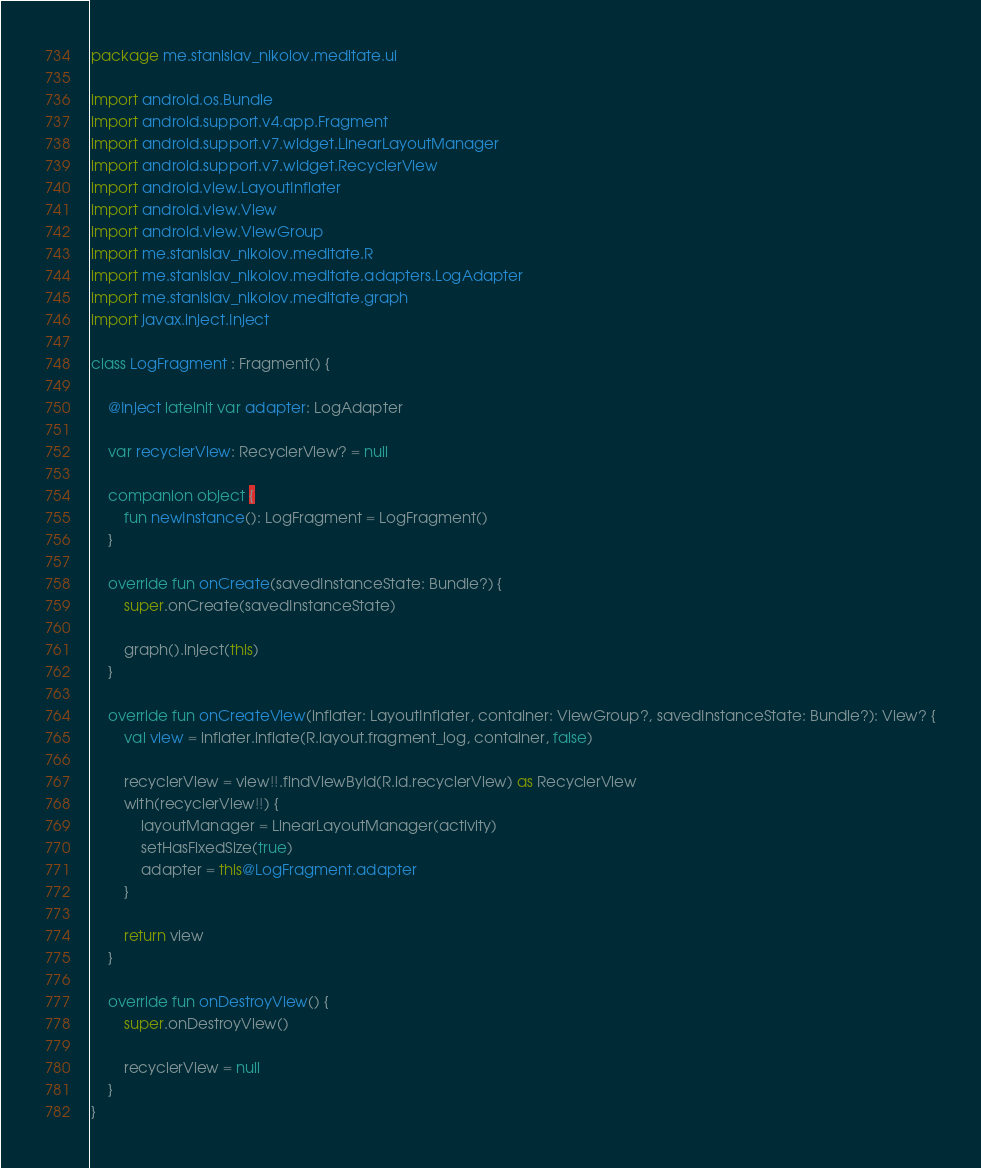Convert code to text. <code><loc_0><loc_0><loc_500><loc_500><_Kotlin_>package me.stanislav_nikolov.meditate.ui

import android.os.Bundle
import android.support.v4.app.Fragment
import android.support.v7.widget.LinearLayoutManager
import android.support.v7.widget.RecyclerView
import android.view.LayoutInflater
import android.view.View
import android.view.ViewGroup
import me.stanislav_nikolov.meditate.R
import me.stanislav_nikolov.meditate.adapters.LogAdapter
import me.stanislav_nikolov.meditate.graph
import javax.inject.Inject

class LogFragment : Fragment() {

    @Inject lateinit var adapter: LogAdapter

    var recyclerView: RecyclerView? = null

    companion object {
        fun newInstance(): LogFragment = LogFragment()
    }

    override fun onCreate(savedInstanceState: Bundle?) {
        super.onCreate(savedInstanceState)

        graph().inject(this)
    }

    override fun onCreateView(inflater: LayoutInflater, container: ViewGroup?, savedInstanceState: Bundle?): View? {
        val view = inflater.inflate(R.layout.fragment_log, container, false)

        recyclerView = view!!.findViewById(R.id.recyclerView) as RecyclerView
        with(recyclerView!!) {
            layoutManager = LinearLayoutManager(activity)
            setHasFixedSize(true)
            adapter = this@LogFragment.adapter
        }

        return view
    }

    override fun onDestroyView() {
        super.onDestroyView()

        recyclerView = null
    }
}
</code> 